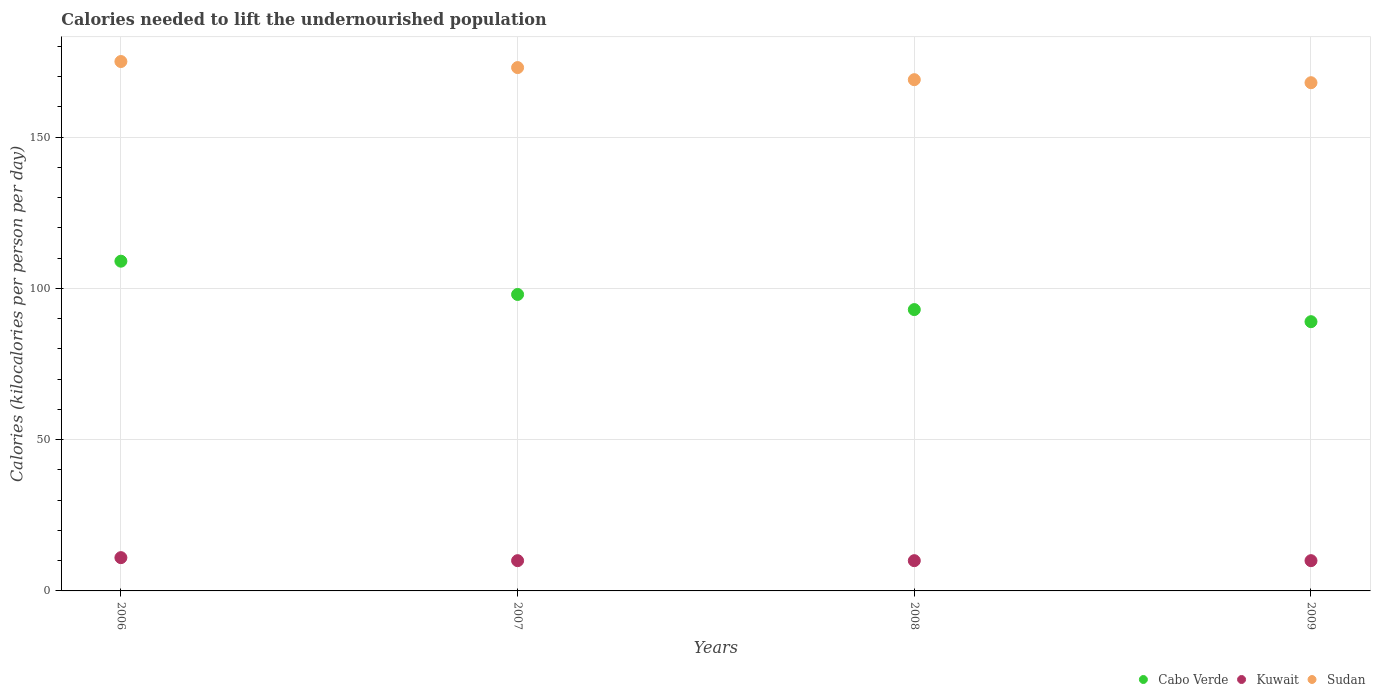How many different coloured dotlines are there?
Provide a succinct answer. 3. Is the number of dotlines equal to the number of legend labels?
Make the answer very short. Yes. What is the total calories needed to lift the undernourished population in Cabo Verde in 2008?
Make the answer very short. 93. Across all years, what is the maximum total calories needed to lift the undernourished population in Cabo Verde?
Your answer should be compact. 109. Across all years, what is the minimum total calories needed to lift the undernourished population in Kuwait?
Provide a succinct answer. 10. In which year was the total calories needed to lift the undernourished population in Sudan maximum?
Offer a very short reply. 2006. In which year was the total calories needed to lift the undernourished population in Cabo Verde minimum?
Ensure brevity in your answer.  2009. What is the total total calories needed to lift the undernourished population in Sudan in the graph?
Offer a terse response. 685. What is the difference between the total calories needed to lift the undernourished population in Cabo Verde in 2007 and that in 2009?
Ensure brevity in your answer.  9. What is the difference between the total calories needed to lift the undernourished population in Cabo Verde in 2006 and the total calories needed to lift the undernourished population in Kuwait in 2007?
Offer a terse response. 99. What is the average total calories needed to lift the undernourished population in Kuwait per year?
Provide a short and direct response. 10.25. In the year 2008, what is the difference between the total calories needed to lift the undernourished population in Kuwait and total calories needed to lift the undernourished population in Cabo Verde?
Provide a succinct answer. -83. In how many years, is the total calories needed to lift the undernourished population in Kuwait greater than 90 kilocalories?
Provide a short and direct response. 0. What is the ratio of the total calories needed to lift the undernourished population in Sudan in 2006 to that in 2007?
Provide a short and direct response. 1.01. Is the total calories needed to lift the undernourished population in Sudan in 2006 less than that in 2007?
Your answer should be compact. No. Is the difference between the total calories needed to lift the undernourished population in Kuwait in 2007 and 2009 greater than the difference between the total calories needed to lift the undernourished population in Cabo Verde in 2007 and 2009?
Provide a succinct answer. No. What is the difference between the highest and the second highest total calories needed to lift the undernourished population in Kuwait?
Your answer should be very brief. 1. What is the difference between the highest and the lowest total calories needed to lift the undernourished population in Kuwait?
Your answer should be very brief. 1. In how many years, is the total calories needed to lift the undernourished population in Kuwait greater than the average total calories needed to lift the undernourished population in Kuwait taken over all years?
Your answer should be very brief. 1. Does the total calories needed to lift the undernourished population in Cabo Verde monotonically increase over the years?
Your answer should be compact. No. How many dotlines are there?
Ensure brevity in your answer.  3. What is the difference between two consecutive major ticks on the Y-axis?
Your answer should be very brief. 50. Does the graph contain grids?
Give a very brief answer. Yes. Where does the legend appear in the graph?
Give a very brief answer. Bottom right. How many legend labels are there?
Your answer should be very brief. 3. How are the legend labels stacked?
Your answer should be compact. Horizontal. What is the title of the graph?
Your answer should be very brief. Calories needed to lift the undernourished population. Does "Lower middle income" appear as one of the legend labels in the graph?
Provide a short and direct response. No. What is the label or title of the X-axis?
Provide a succinct answer. Years. What is the label or title of the Y-axis?
Provide a short and direct response. Calories (kilocalories per person per day). What is the Calories (kilocalories per person per day) in Cabo Verde in 2006?
Provide a succinct answer. 109. What is the Calories (kilocalories per person per day) in Kuwait in 2006?
Offer a terse response. 11. What is the Calories (kilocalories per person per day) in Sudan in 2006?
Offer a very short reply. 175. What is the Calories (kilocalories per person per day) of Sudan in 2007?
Provide a succinct answer. 173. What is the Calories (kilocalories per person per day) in Cabo Verde in 2008?
Provide a short and direct response. 93. What is the Calories (kilocalories per person per day) of Kuwait in 2008?
Ensure brevity in your answer.  10. What is the Calories (kilocalories per person per day) in Sudan in 2008?
Offer a very short reply. 169. What is the Calories (kilocalories per person per day) in Cabo Verde in 2009?
Keep it short and to the point. 89. What is the Calories (kilocalories per person per day) of Kuwait in 2009?
Your answer should be compact. 10. What is the Calories (kilocalories per person per day) in Sudan in 2009?
Make the answer very short. 168. Across all years, what is the maximum Calories (kilocalories per person per day) of Cabo Verde?
Ensure brevity in your answer.  109. Across all years, what is the maximum Calories (kilocalories per person per day) of Sudan?
Your response must be concise. 175. Across all years, what is the minimum Calories (kilocalories per person per day) in Cabo Verde?
Offer a very short reply. 89. Across all years, what is the minimum Calories (kilocalories per person per day) of Sudan?
Ensure brevity in your answer.  168. What is the total Calories (kilocalories per person per day) in Cabo Verde in the graph?
Offer a very short reply. 389. What is the total Calories (kilocalories per person per day) in Sudan in the graph?
Offer a terse response. 685. What is the difference between the Calories (kilocalories per person per day) of Kuwait in 2006 and that in 2007?
Provide a succinct answer. 1. What is the difference between the Calories (kilocalories per person per day) in Cabo Verde in 2006 and that in 2008?
Offer a terse response. 16. What is the difference between the Calories (kilocalories per person per day) in Sudan in 2006 and that in 2008?
Make the answer very short. 6. What is the difference between the Calories (kilocalories per person per day) in Cabo Verde in 2006 and that in 2009?
Provide a short and direct response. 20. What is the difference between the Calories (kilocalories per person per day) of Kuwait in 2006 and that in 2009?
Provide a succinct answer. 1. What is the difference between the Calories (kilocalories per person per day) of Sudan in 2006 and that in 2009?
Ensure brevity in your answer.  7. What is the difference between the Calories (kilocalories per person per day) in Cabo Verde in 2007 and that in 2008?
Offer a very short reply. 5. What is the difference between the Calories (kilocalories per person per day) of Cabo Verde in 2008 and that in 2009?
Keep it short and to the point. 4. What is the difference between the Calories (kilocalories per person per day) in Sudan in 2008 and that in 2009?
Make the answer very short. 1. What is the difference between the Calories (kilocalories per person per day) in Cabo Verde in 2006 and the Calories (kilocalories per person per day) in Kuwait in 2007?
Your answer should be compact. 99. What is the difference between the Calories (kilocalories per person per day) of Cabo Verde in 2006 and the Calories (kilocalories per person per day) of Sudan in 2007?
Make the answer very short. -64. What is the difference between the Calories (kilocalories per person per day) in Kuwait in 2006 and the Calories (kilocalories per person per day) in Sudan in 2007?
Offer a terse response. -162. What is the difference between the Calories (kilocalories per person per day) in Cabo Verde in 2006 and the Calories (kilocalories per person per day) in Kuwait in 2008?
Your answer should be very brief. 99. What is the difference between the Calories (kilocalories per person per day) of Cabo Verde in 2006 and the Calories (kilocalories per person per day) of Sudan in 2008?
Make the answer very short. -60. What is the difference between the Calories (kilocalories per person per day) of Kuwait in 2006 and the Calories (kilocalories per person per day) of Sudan in 2008?
Offer a very short reply. -158. What is the difference between the Calories (kilocalories per person per day) of Cabo Verde in 2006 and the Calories (kilocalories per person per day) of Sudan in 2009?
Ensure brevity in your answer.  -59. What is the difference between the Calories (kilocalories per person per day) in Kuwait in 2006 and the Calories (kilocalories per person per day) in Sudan in 2009?
Offer a terse response. -157. What is the difference between the Calories (kilocalories per person per day) in Cabo Verde in 2007 and the Calories (kilocalories per person per day) in Sudan in 2008?
Provide a succinct answer. -71. What is the difference between the Calories (kilocalories per person per day) of Kuwait in 2007 and the Calories (kilocalories per person per day) of Sudan in 2008?
Your answer should be very brief. -159. What is the difference between the Calories (kilocalories per person per day) of Cabo Verde in 2007 and the Calories (kilocalories per person per day) of Sudan in 2009?
Provide a succinct answer. -70. What is the difference between the Calories (kilocalories per person per day) of Kuwait in 2007 and the Calories (kilocalories per person per day) of Sudan in 2009?
Provide a short and direct response. -158. What is the difference between the Calories (kilocalories per person per day) of Cabo Verde in 2008 and the Calories (kilocalories per person per day) of Sudan in 2009?
Provide a succinct answer. -75. What is the difference between the Calories (kilocalories per person per day) in Kuwait in 2008 and the Calories (kilocalories per person per day) in Sudan in 2009?
Ensure brevity in your answer.  -158. What is the average Calories (kilocalories per person per day) in Cabo Verde per year?
Your answer should be very brief. 97.25. What is the average Calories (kilocalories per person per day) in Kuwait per year?
Offer a terse response. 10.25. What is the average Calories (kilocalories per person per day) of Sudan per year?
Make the answer very short. 171.25. In the year 2006, what is the difference between the Calories (kilocalories per person per day) of Cabo Verde and Calories (kilocalories per person per day) of Kuwait?
Provide a short and direct response. 98. In the year 2006, what is the difference between the Calories (kilocalories per person per day) in Cabo Verde and Calories (kilocalories per person per day) in Sudan?
Provide a short and direct response. -66. In the year 2006, what is the difference between the Calories (kilocalories per person per day) of Kuwait and Calories (kilocalories per person per day) of Sudan?
Your response must be concise. -164. In the year 2007, what is the difference between the Calories (kilocalories per person per day) in Cabo Verde and Calories (kilocalories per person per day) in Kuwait?
Offer a terse response. 88. In the year 2007, what is the difference between the Calories (kilocalories per person per day) in Cabo Verde and Calories (kilocalories per person per day) in Sudan?
Your answer should be very brief. -75. In the year 2007, what is the difference between the Calories (kilocalories per person per day) of Kuwait and Calories (kilocalories per person per day) of Sudan?
Provide a succinct answer. -163. In the year 2008, what is the difference between the Calories (kilocalories per person per day) in Cabo Verde and Calories (kilocalories per person per day) in Kuwait?
Your answer should be very brief. 83. In the year 2008, what is the difference between the Calories (kilocalories per person per day) of Cabo Verde and Calories (kilocalories per person per day) of Sudan?
Your answer should be compact. -76. In the year 2008, what is the difference between the Calories (kilocalories per person per day) in Kuwait and Calories (kilocalories per person per day) in Sudan?
Your response must be concise. -159. In the year 2009, what is the difference between the Calories (kilocalories per person per day) of Cabo Verde and Calories (kilocalories per person per day) of Kuwait?
Your response must be concise. 79. In the year 2009, what is the difference between the Calories (kilocalories per person per day) in Cabo Verde and Calories (kilocalories per person per day) in Sudan?
Make the answer very short. -79. In the year 2009, what is the difference between the Calories (kilocalories per person per day) of Kuwait and Calories (kilocalories per person per day) of Sudan?
Offer a very short reply. -158. What is the ratio of the Calories (kilocalories per person per day) of Cabo Verde in 2006 to that in 2007?
Your answer should be very brief. 1.11. What is the ratio of the Calories (kilocalories per person per day) in Sudan in 2006 to that in 2007?
Offer a terse response. 1.01. What is the ratio of the Calories (kilocalories per person per day) in Cabo Verde in 2006 to that in 2008?
Ensure brevity in your answer.  1.17. What is the ratio of the Calories (kilocalories per person per day) in Sudan in 2006 to that in 2008?
Give a very brief answer. 1.04. What is the ratio of the Calories (kilocalories per person per day) of Cabo Verde in 2006 to that in 2009?
Offer a very short reply. 1.22. What is the ratio of the Calories (kilocalories per person per day) of Kuwait in 2006 to that in 2009?
Your answer should be compact. 1.1. What is the ratio of the Calories (kilocalories per person per day) of Sudan in 2006 to that in 2009?
Give a very brief answer. 1.04. What is the ratio of the Calories (kilocalories per person per day) of Cabo Verde in 2007 to that in 2008?
Your response must be concise. 1.05. What is the ratio of the Calories (kilocalories per person per day) of Kuwait in 2007 to that in 2008?
Provide a short and direct response. 1. What is the ratio of the Calories (kilocalories per person per day) of Sudan in 2007 to that in 2008?
Your answer should be compact. 1.02. What is the ratio of the Calories (kilocalories per person per day) in Cabo Verde in 2007 to that in 2009?
Make the answer very short. 1.1. What is the ratio of the Calories (kilocalories per person per day) of Sudan in 2007 to that in 2009?
Give a very brief answer. 1.03. What is the ratio of the Calories (kilocalories per person per day) of Cabo Verde in 2008 to that in 2009?
Provide a short and direct response. 1.04. What is the ratio of the Calories (kilocalories per person per day) in Kuwait in 2008 to that in 2009?
Provide a short and direct response. 1. What is the difference between the highest and the second highest Calories (kilocalories per person per day) of Kuwait?
Offer a very short reply. 1. What is the difference between the highest and the lowest Calories (kilocalories per person per day) of Cabo Verde?
Keep it short and to the point. 20. What is the difference between the highest and the lowest Calories (kilocalories per person per day) in Sudan?
Give a very brief answer. 7. 